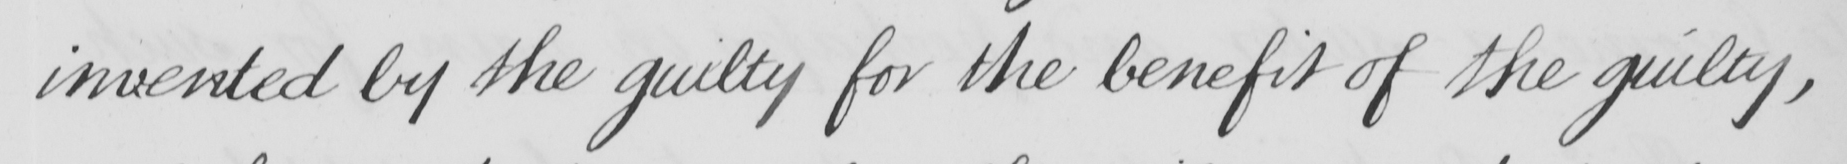Can you tell me what this handwritten text says? invented by the guilty for the benefit of the guilty , 